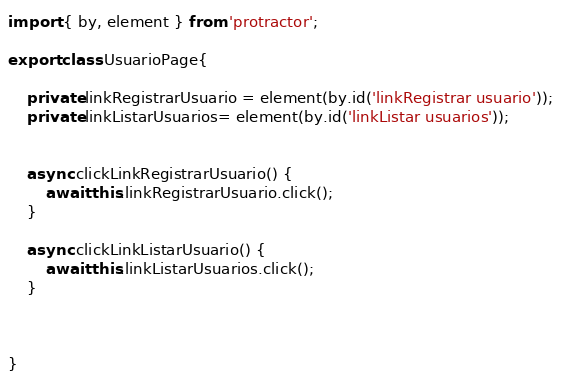<code> <loc_0><loc_0><loc_500><loc_500><_TypeScript_>import { by, element } from 'protractor';

export class UsuarioPage{

    private linkRegistrarUsuario = element(by.id('linkRegistrar usuario'));
    private linkListarUsuarios= element(by.id('linkListar usuarios'));
    

    async clickLinkRegistrarUsuario() {
        await this.linkRegistrarUsuario.click();
    }

    async clickLinkListarUsuario() {
        await this.linkListarUsuarios.click();
    }

  

}</code> 